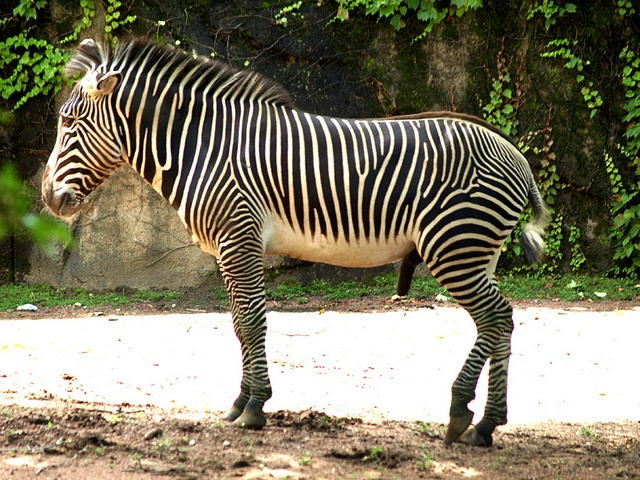Describe the objects in this image and their specific colors. I can see a zebra in black, beige, tan, and khaki tones in this image. 